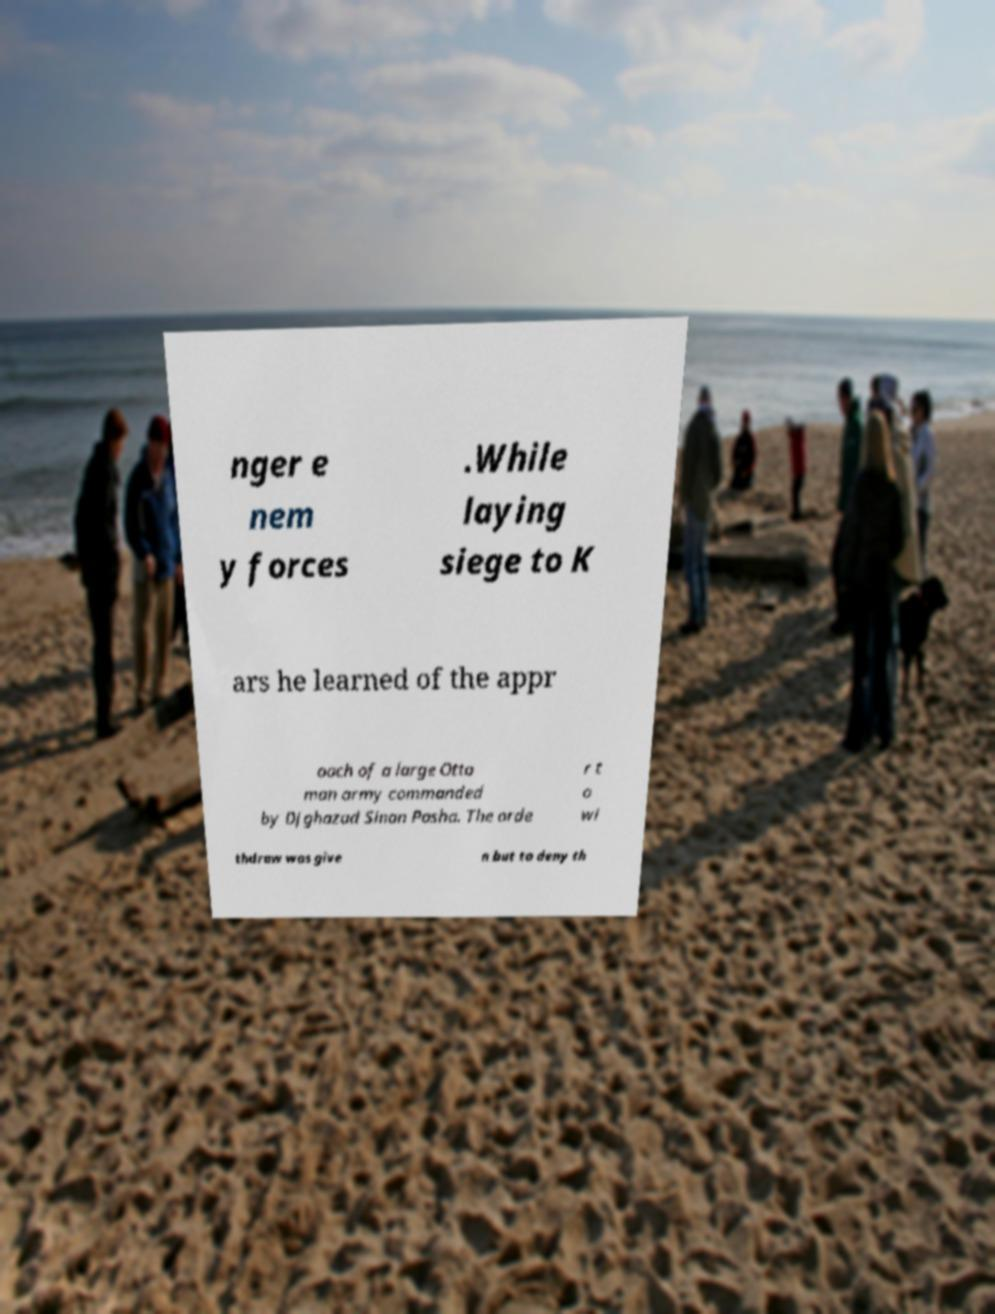Please read and relay the text visible in this image. What does it say? nger e nem y forces .While laying siege to K ars he learned of the appr oach of a large Otto man army commanded by Djghazad Sinan Pasha. The orde r t o wi thdraw was give n but to deny th 